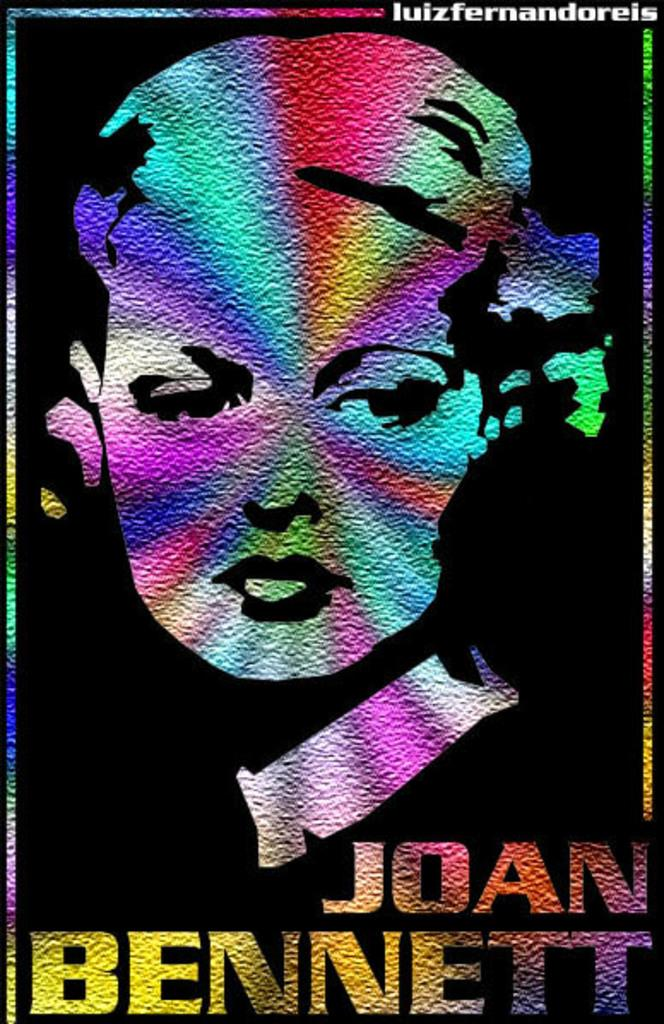What is the main subject of the picture? There is a colorful image of a woman in the picture. How is the image of the woman being displayed? The image is displayed on a screen or display. Are there any cobwebs visible on the screen displaying the image of the woman? There is no mention of cobwebs in the provided facts, so we cannot determine if any are present. How many kittens are sitting on the woman's lap in the image? There is no mention of kittens in the provided facts, so we cannot determine if any are present. 